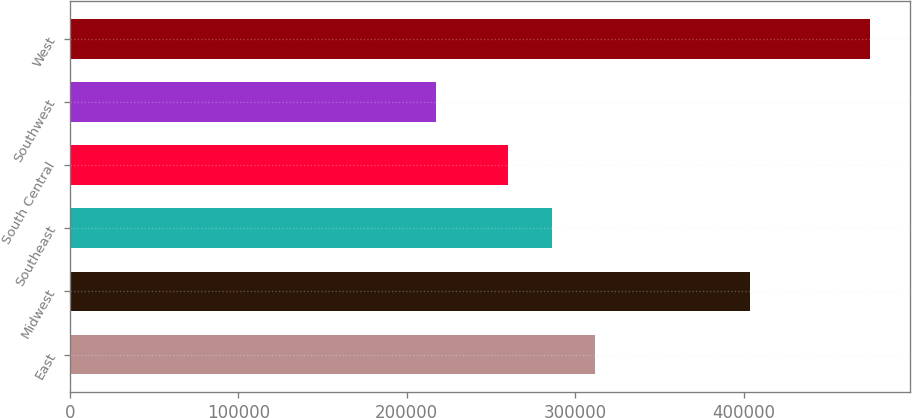<chart> <loc_0><loc_0><loc_500><loc_500><bar_chart><fcel>East<fcel>Midwest<fcel>Southeast<fcel>South Central<fcel>Southwest<fcel>West<nl><fcel>311800<fcel>403900<fcel>286000<fcel>260200<fcel>217200<fcel>475200<nl></chart> 